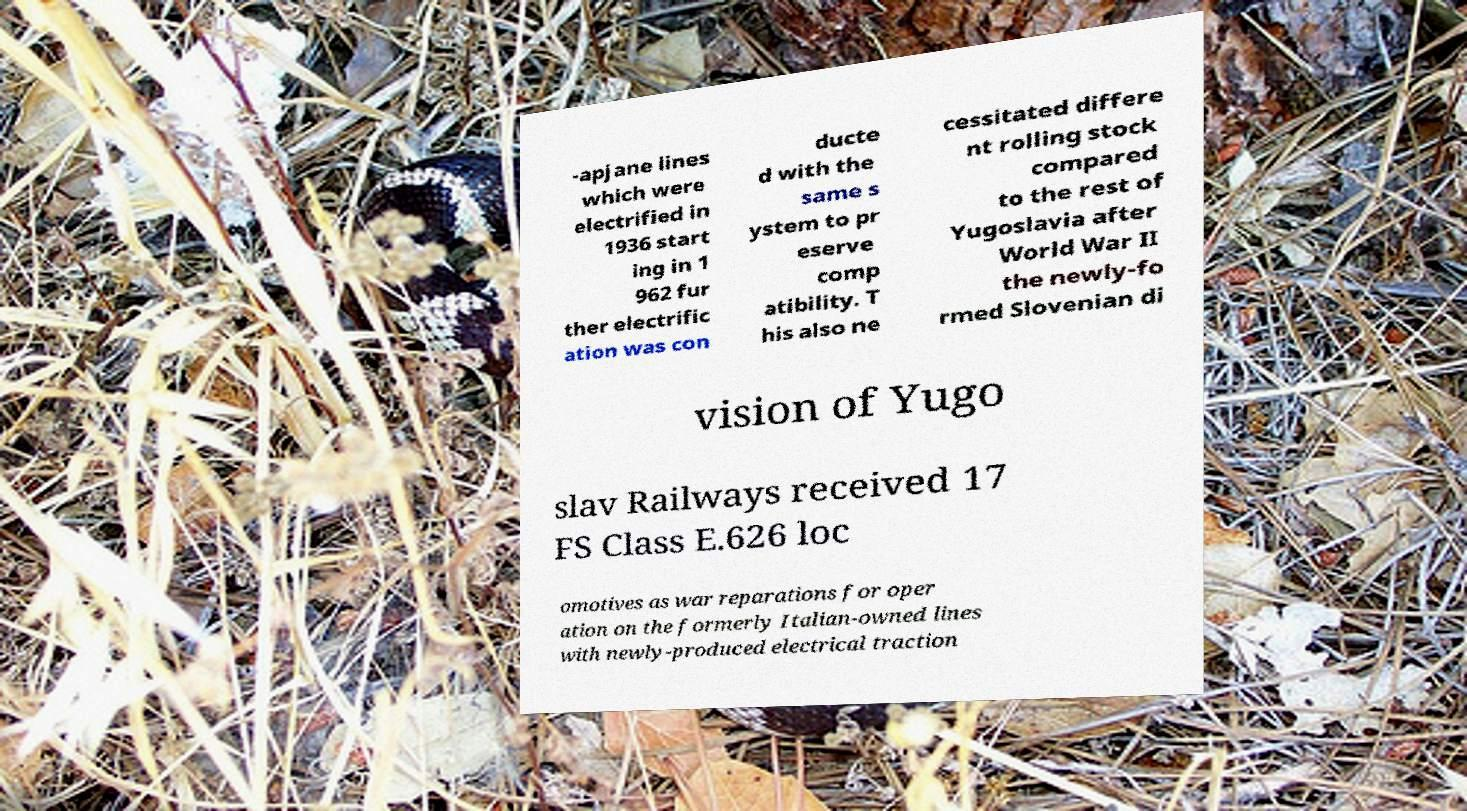Please identify and transcribe the text found in this image. -apjane lines which were electrified in 1936 start ing in 1 962 fur ther electrific ation was con ducte d with the same s ystem to pr eserve comp atibility. T his also ne cessitated differe nt rolling stock compared to the rest of Yugoslavia after World War II the newly-fo rmed Slovenian di vision of Yugo slav Railways received 17 FS Class E.626 loc omotives as war reparations for oper ation on the formerly Italian-owned lines with newly-produced electrical traction 